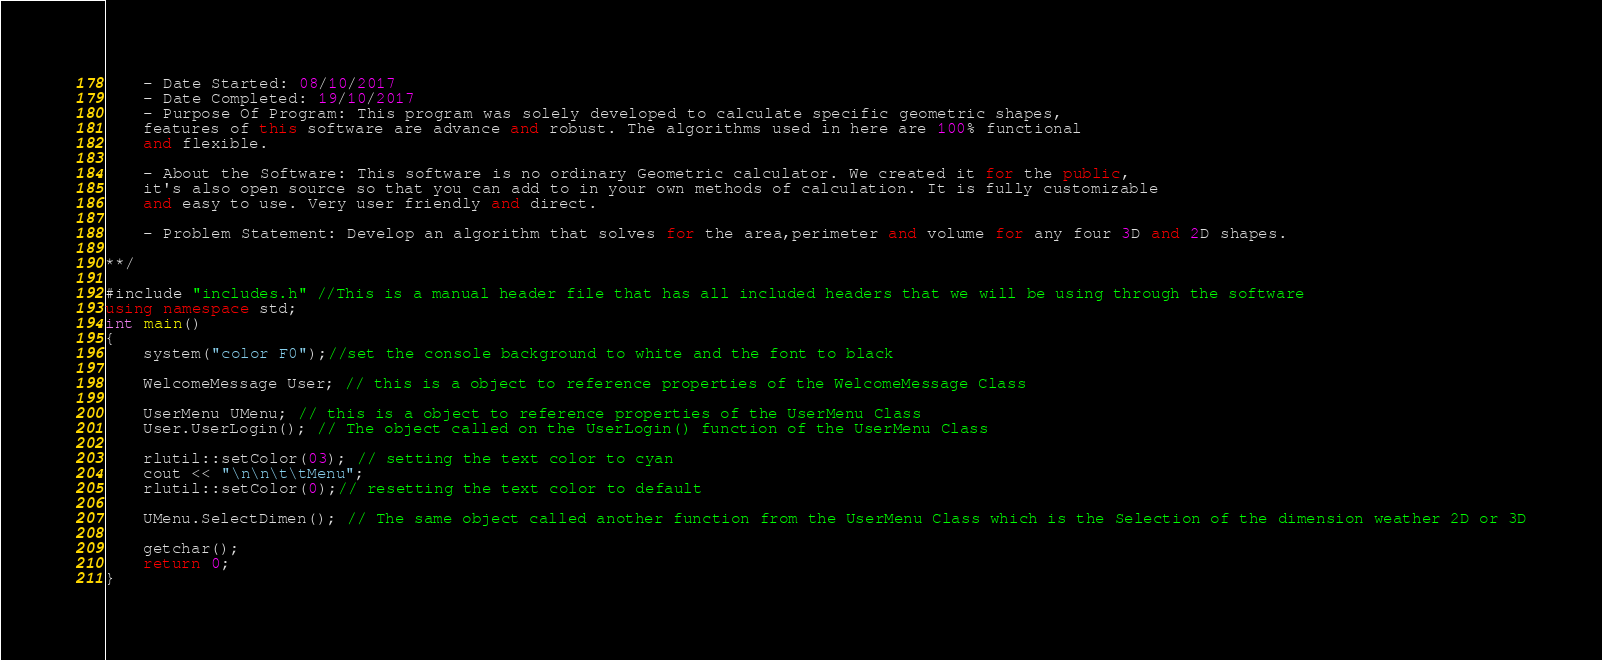Convert code to text. <code><loc_0><loc_0><loc_500><loc_500><_C++_>    - Date Started: 08/10/2017
    - Date Completed: 19/10/2017
    - Purpose Of Program: This program was solely developed to calculate specific geometric shapes,
    features of this software are advance and robust. The algorithms used in here are 100% functional
    and flexible.

    - About the Software: This software is no ordinary Geometric calculator. We created it for the public,
    it's also open source so that you can add to in your own methods of calculation. It is fully customizable
    and easy to use. Very user friendly and direct.

    - Problem Statement: Develop an algorithm that solves for the area,perimeter and volume for any four 3D and 2D shapes.

**/

#include "includes.h" //This is a manual header file that has all included headers that we will be using through the software
using namespace std;
int main()
{
    system("color F0");//set the console background to white and the font to black

    WelcomeMessage User; // this is a object to reference properties of the WelcomeMessage Class

    UserMenu UMenu; // this is a object to reference properties of the UserMenu Class
    User.UserLogin(); // The object called on the UserLogin() function of the UserMenu Class

    rlutil::setColor(03); // setting the text color to cyan
    cout << "\n\n\t\tMenu";
    rlutil::setColor(0);// resetting the text color to default

    UMenu.SelectDimen(); // The same object called another function from the UserMenu Class which is the Selection of the dimension weather 2D or 3D

    getchar();
    return 0;
}

</code> 